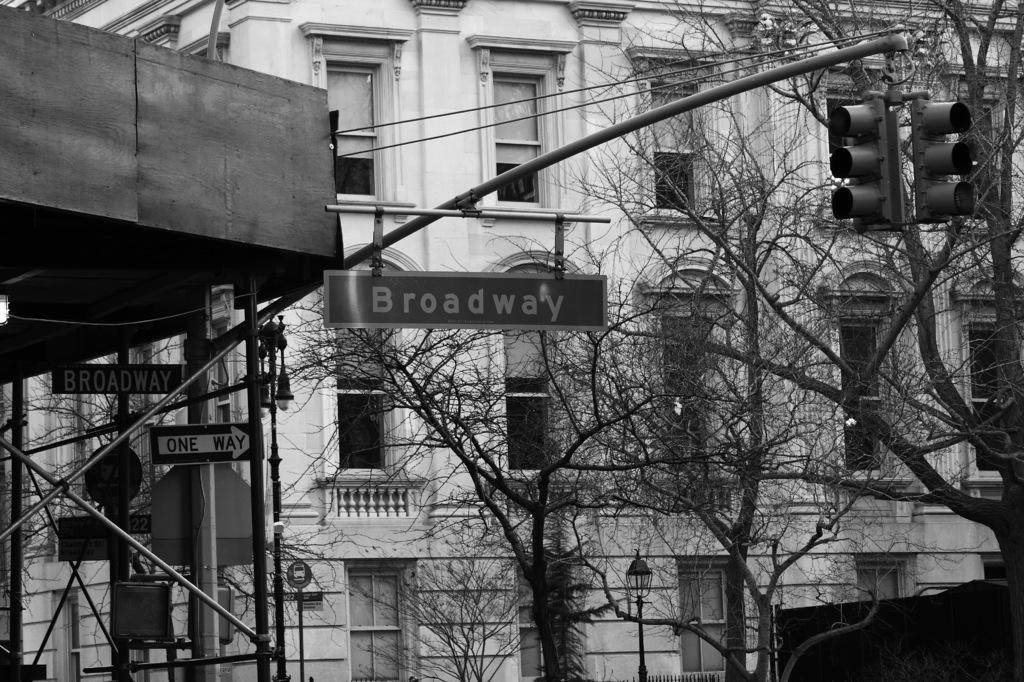Describe this image in one or two sentences. In this image we can see a black and white picture of a building with windows. To the left side of the image we can see a metal container, group of poles, signboards with text. To the right side of the image we can see traffic lights, a group of trees and the light poles. 